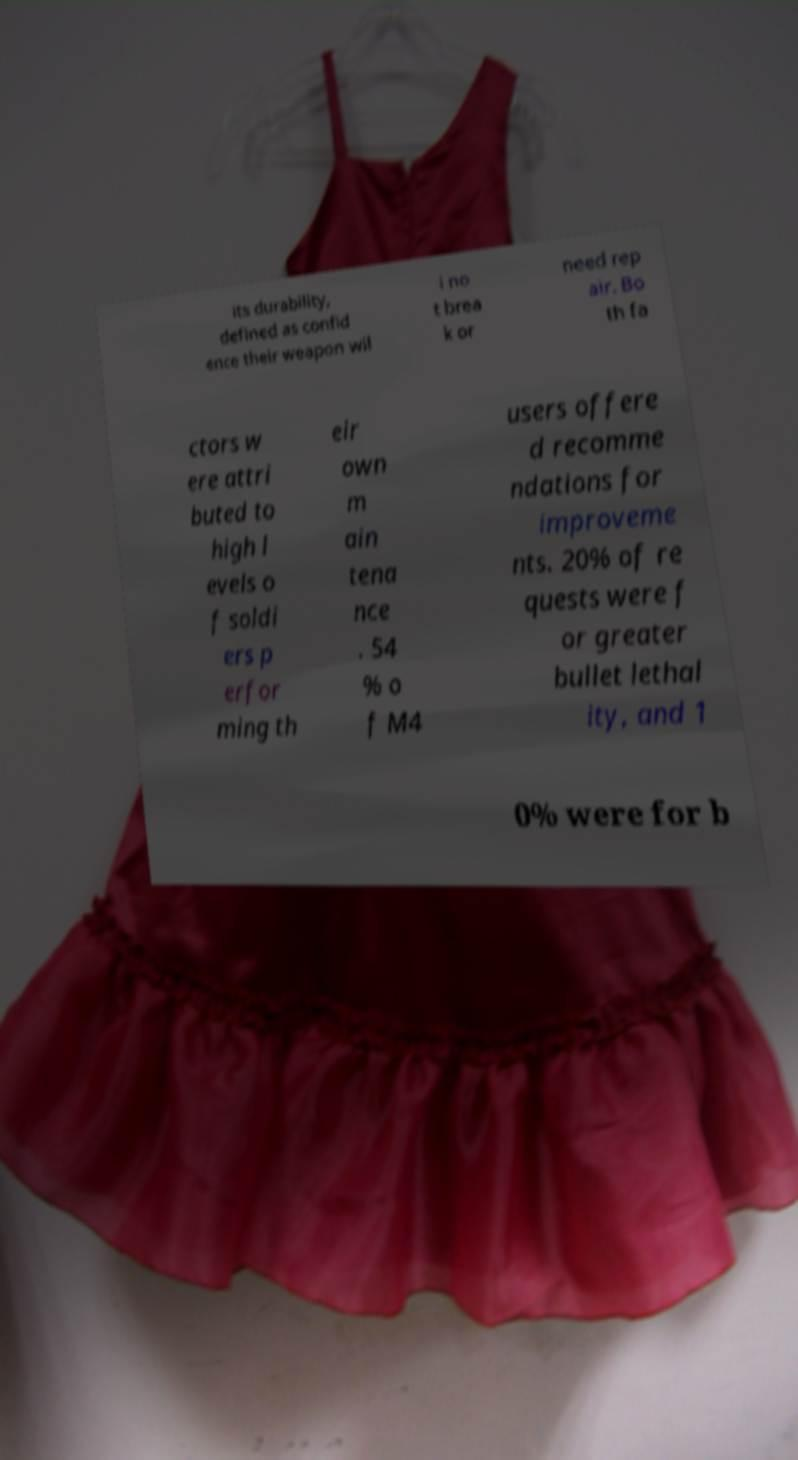For documentation purposes, I need the text within this image transcribed. Could you provide that? its durability, defined as confid ence their weapon wil l no t brea k or need rep air. Bo th fa ctors w ere attri buted to high l evels o f soldi ers p erfor ming th eir own m ain tena nce . 54 % o f M4 users offere d recomme ndations for improveme nts. 20% of re quests were f or greater bullet lethal ity, and 1 0% were for b 